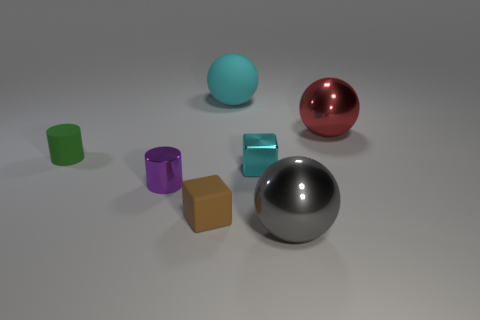Subtract all big red metallic spheres. How many spheres are left? 2 Subtract 1 spheres. How many spheres are left? 2 Add 2 small rubber objects. How many objects exist? 9 Subtract all brown spheres. Subtract all green cylinders. How many spheres are left? 3 Subtract all balls. How many objects are left? 4 Add 5 green objects. How many green objects exist? 6 Subtract 1 red spheres. How many objects are left? 6 Subtract all large cyan things. Subtract all big cyan things. How many objects are left? 5 Add 7 cyan matte balls. How many cyan matte balls are left? 8 